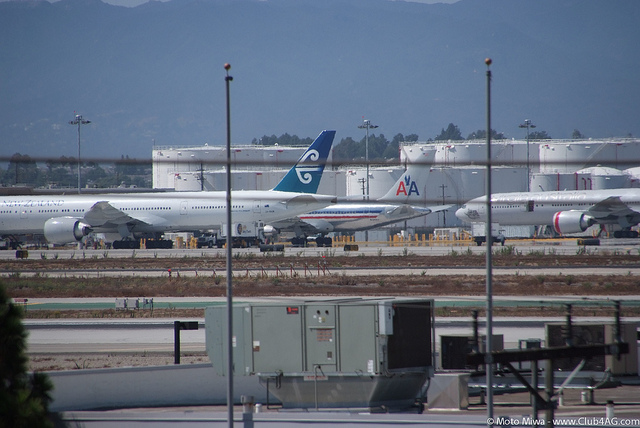<image>Which of these vehicles would float? None of the vehicles would float. Which of these vehicles would float? I don't know which of these vehicles would float. None of the vehicles are shown in the image. 